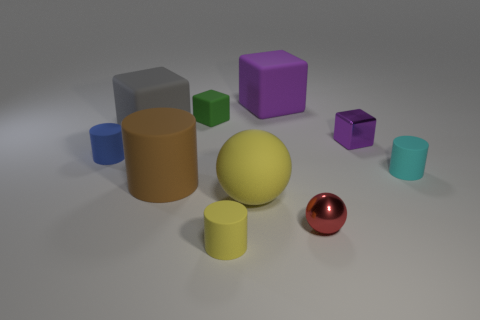Is the number of rubber balls that are behind the big gray object the same as the number of brown metal blocks?
Ensure brevity in your answer.  Yes. How big is the matte block on the left side of the brown cylinder?
Make the answer very short. Large. What number of red objects are the same shape as the tiny cyan thing?
Provide a short and direct response. 0. The small cylinder that is both to the right of the small green rubber block and on the left side of the cyan rubber object is made of what material?
Provide a succinct answer. Rubber. Is the tiny blue object made of the same material as the brown cylinder?
Provide a short and direct response. Yes. How many tiny cyan metal objects are there?
Keep it short and to the point. 0. There is a tiny cylinder that is right of the tiny red object to the right of the small cylinder that is to the left of the green matte block; what is its color?
Provide a succinct answer. Cyan. Does the large rubber cylinder have the same color as the large sphere?
Offer a very short reply. No. What number of cylinders are in front of the small cyan rubber thing and left of the small yellow rubber object?
Offer a very short reply. 1. How many matte objects are either green cubes or gray blocks?
Your answer should be very brief. 2. 